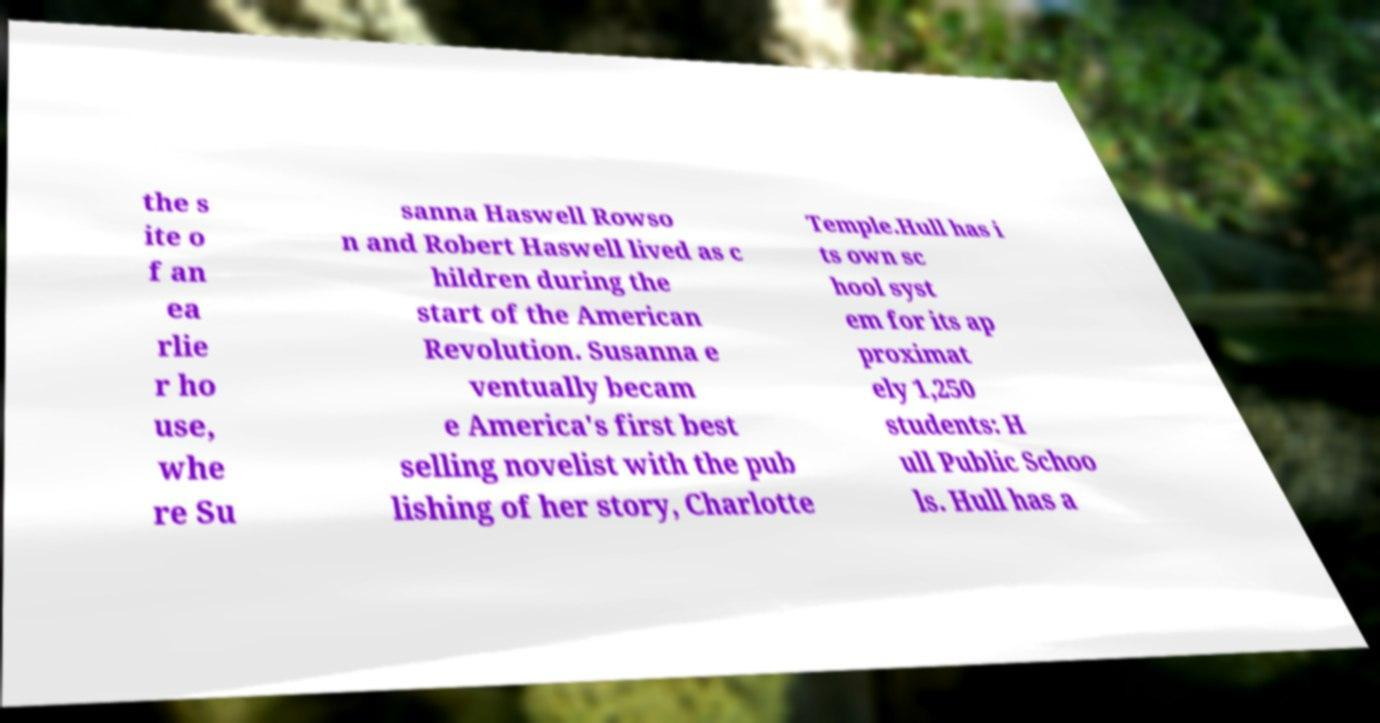Could you assist in decoding the text presented in this image and type it out clearly? the s ite o f an ea rlie r ho use, whe re Su sanna Haswell Rowso n and Robert Haswell lived as c hildren during the start of the American Revolution. Susanna e ventually becam e America's first best selling novelist with the pub lishing of her story, Charlotte Temple.Hull has i ts own sc hool syst em for its ap proximat ely 1,250 students: H ull Public Schoo ls. Hull has a 